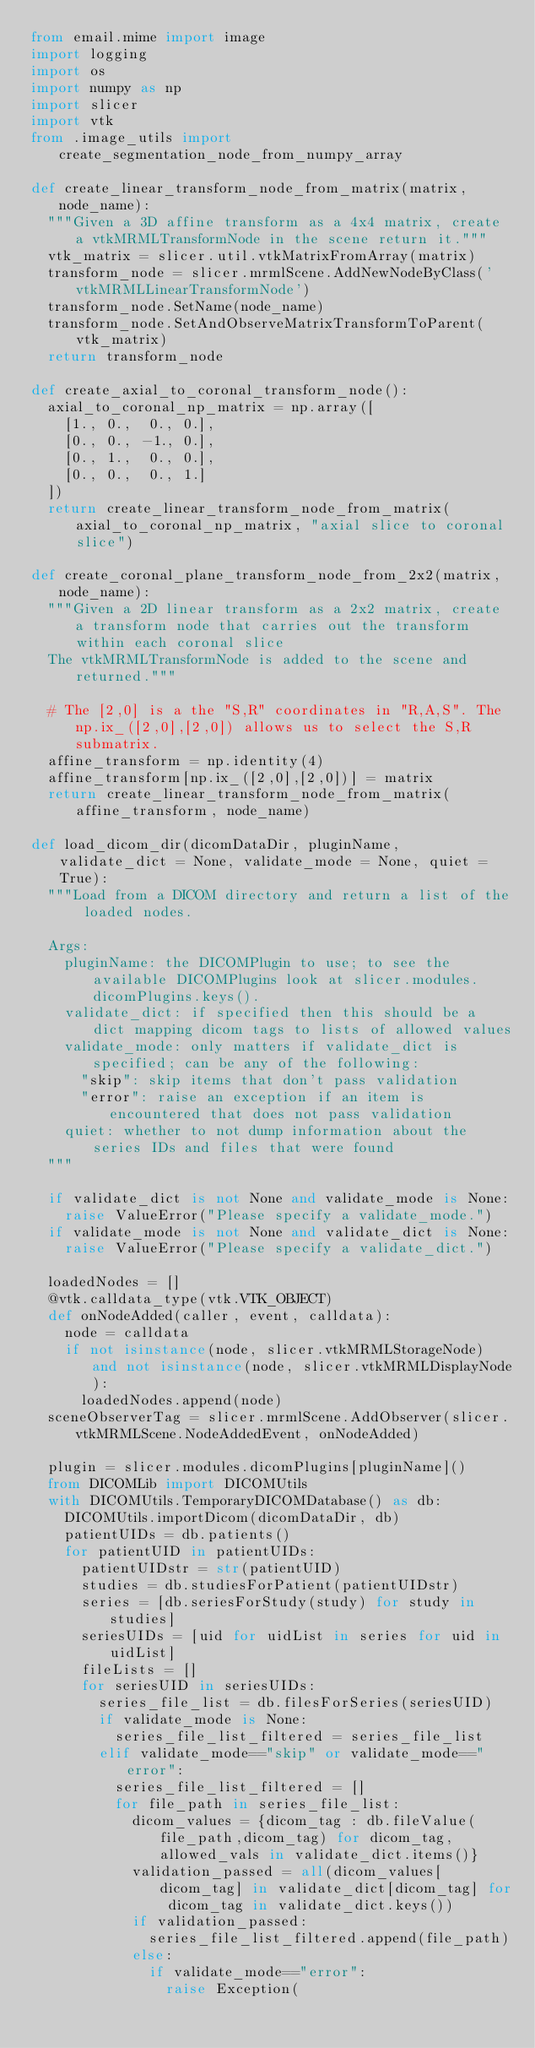<code> <loc_0><loc_0><loc_500><loc_500><_Python_>from email.mime import image
import logging
import os
import numpy as np
import slicer
import vtk
from .image_utils import create_segmentation_node_from_numpy_array

def create_linear_transform_node_from_matrix(matrix, node_name):
  """Given a 3D affine transform as a 4x4 matrix, create a vtkMRMLTransformNode in the scene return it."""
  vtk_matrix = slicer.util.vtkMatrixFromArray(matrix)
  transform_node = slicer.mrmlScene.AddNewNodeByClass('vtkMRMLLinearTransformNode')
  transform_node.SetName(node_name)
  transform_node.SetAndObserveMatrixTransformToParent(vtk_matrix)
  return transform_node

def create_axial_to_coronal_transform_node():
  axial_to_coronal_np_matrix = np.array([
    [1., 0.,  0., 0.],
    [0., 0., -1., 0.],
    [0., 1.,  0., 0.],
    [0., 0.,  0., 1.]
  ])
  return create_linear_transform_node_from_matrix(axial_to_coronal_np_matrix, "axial slice to coronal slice")

def create_coronal_plane_transform_node_from_2x2(matrix, node_name):
  """Given a 2D linear transform as a 2x2 matrix, create a transform node that carries out the transform within each coronal slice
  The vtkMRMLTransformNode is added to the scene and returned."""

  # The [2,0] is a the "S,R" coordinates in "R,A,S". The np.ix_([2,0],[2,0]) allows us to select the S,R submatrix.
  affine_transform = np.identity(4)
  affine_transform[np.ix_([2,0],[2,0])] = matrix
  return create_linear_transform_node_from_matrix(affine_transform, node_name)

def load_dicom_dir(dicomDataDir, pluginName, validate_dict = None, validate_mode = None, quiet = True):
  """Load from a DICOM directory and return a list of the loaded nodes.

  Args:
    pluginName: the DICOMPlugin to use; to see the available DICOMPlugins look at slicer.modules.dicomPlugins.keys().
    validate_dict: if specified then this should be a dict mapping dicom tags to lists of allowed values
    validate_mode: only matters if validate_dict is specified; can be any of the following:
      "skip": skip items that don't pass validation
      "error": raise an exception if an item is encountered that does not pass validation
    quiet: whether to not dump information about the series IDs and files that were found
  """

  if validate_dict is not None and validate_mode is None:
    raise ValueError("Please specify a validate_mode.")
  if validate_mode is not None and validate_dict is None:
    raise ValueError("Please specify a validate_dict.")

  loadedNodes = []
  @vtk.calldata_type(vtk.VTK_OBJECT)
  def onNodeAdded(caller, event, calldata):
    node = calldata
    if not isinstance(node, slicer.vtkMRMLStorageNode) and not isinstance(node, slicer.vtkMRMLDisplayNode):
      loadedNodes.append(node)
  sceneObserverTag = slicer.mrmlScene.AddObserver(slicer.vtkMRMLScene.NodeAddedEvent, onNodeAdded)

  plugin = slicer.modules.dicomPlugins[pluginName]()
  from DICOMLib import DICOMUtils
  with DICOMUtils.TemporaryDICOMDatabase() as db:
    DICOMUtils.importDicom(dicomDataDir, db)
    patientUIDs = db.patients()
    for patientUID in patientUIDs:
      patientUIDstr = str(patientUID)
      studies = db.studiesForPatient(patientUIDstr)
      series = [db.seriesForStudy(study) for study in studies]
      seriesUIDs = [uid for uidList in series for uid in uidList]
      fileLists = []
      for seriesUID in seriesUIDs:
        series_file_list = db.filesForSeries(seriesUID)
        if validate_mode is None:
          series_file_list_filtered = series_file_list
        elif validate_mode=="skip" or validate_mode=="error":
          series_file_list_filtered = []
          for file_path in series_file_list:
            dicom_values = {dicom_tag : db.fileValue(file_path,dicom_tag) for dicom_tag, allowed_vals in validate_dict.items()}
            validation_passed = all(dicom_values[dicom_tag] in validate_dict[dicom_tag] for dicom_tag in validate_dict.keys())
            if validation_passed:
              series_file_list_filtered.append(file_path)
            else:
              if validate_mode=="error":
                raise Exception(</code> 